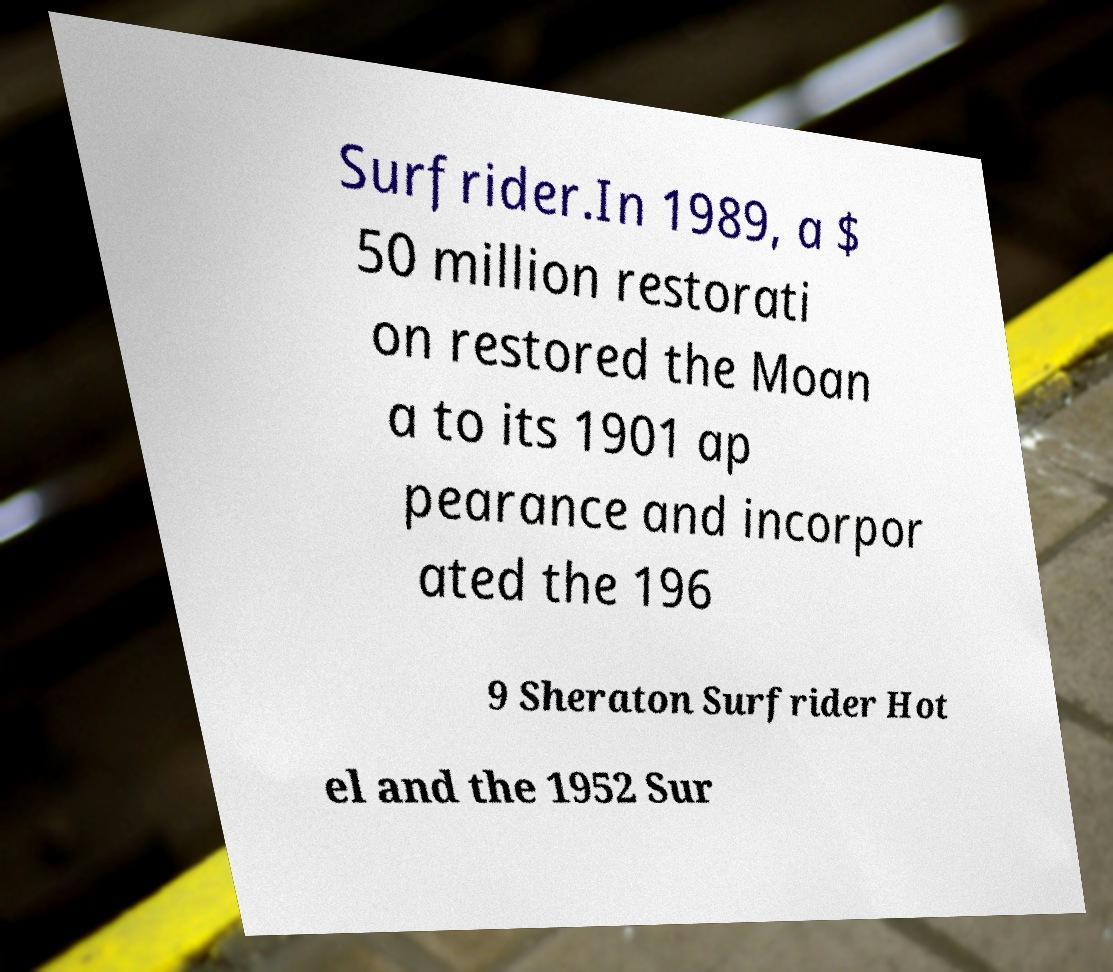Please identify and transcribe the text found in this image. Surfrider.In 1989, a $ 50 million restorati on restored the Moan a to its 1901 ap pearance and incorpor ated the 196 9 Sheraton Surfrider Hot el and the 1952 Sur 